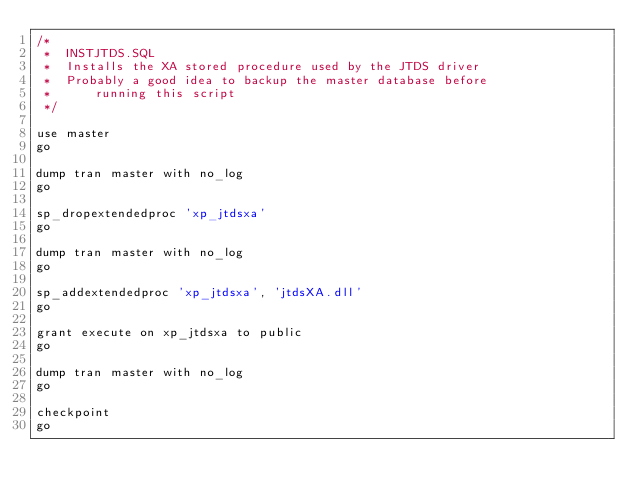<code> <loc_0><loc_0><loc_500><loc_500><_SQL_>/*
 *	INSTJTDS.SQL
 *	Installs the XA stored procedure used by the JTDS driver 
 * 	Probably a good idea to backup the master database before 
 *      running this script
 */

use master
go

dump tran master with no_log
go

sp_dropextendedproc 'xp_jtdsxa' 
go

dump tran master with no_log
go

sp_addextendedproc 'xp_jtdsxa', 'jtdsXA.dll'
go

grant execute on xp_jtdsxa to public
go

dump tran master with no_log
go

checkpoint
go

</code> 